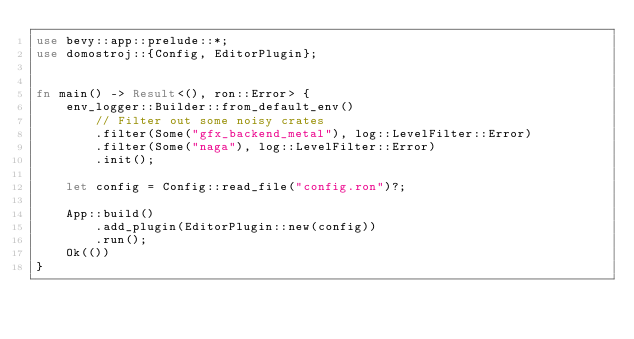<code> <loc_0><loc_0><loc_500><loc_500><_Rust_>use bevy::app::prelude::*;
use domostroj::{Config, EditorPlugin};


fn main() -> Result<(), ron::Error> {
    env_logger::Builder::from_default_env()
        // Filter out some noisy crates
        .filter(Some("gfx_backend_metal"), log::LevelFilter::Error)
        .filter(Some("naga"), log::LevelFilter::Error)
        .init();

    let config = Config::read_file("config.ron")?;

    App::build()
        .add_plugin(EditorPlugin::new(config))
        .run();
    Ok(())
}
</code> 